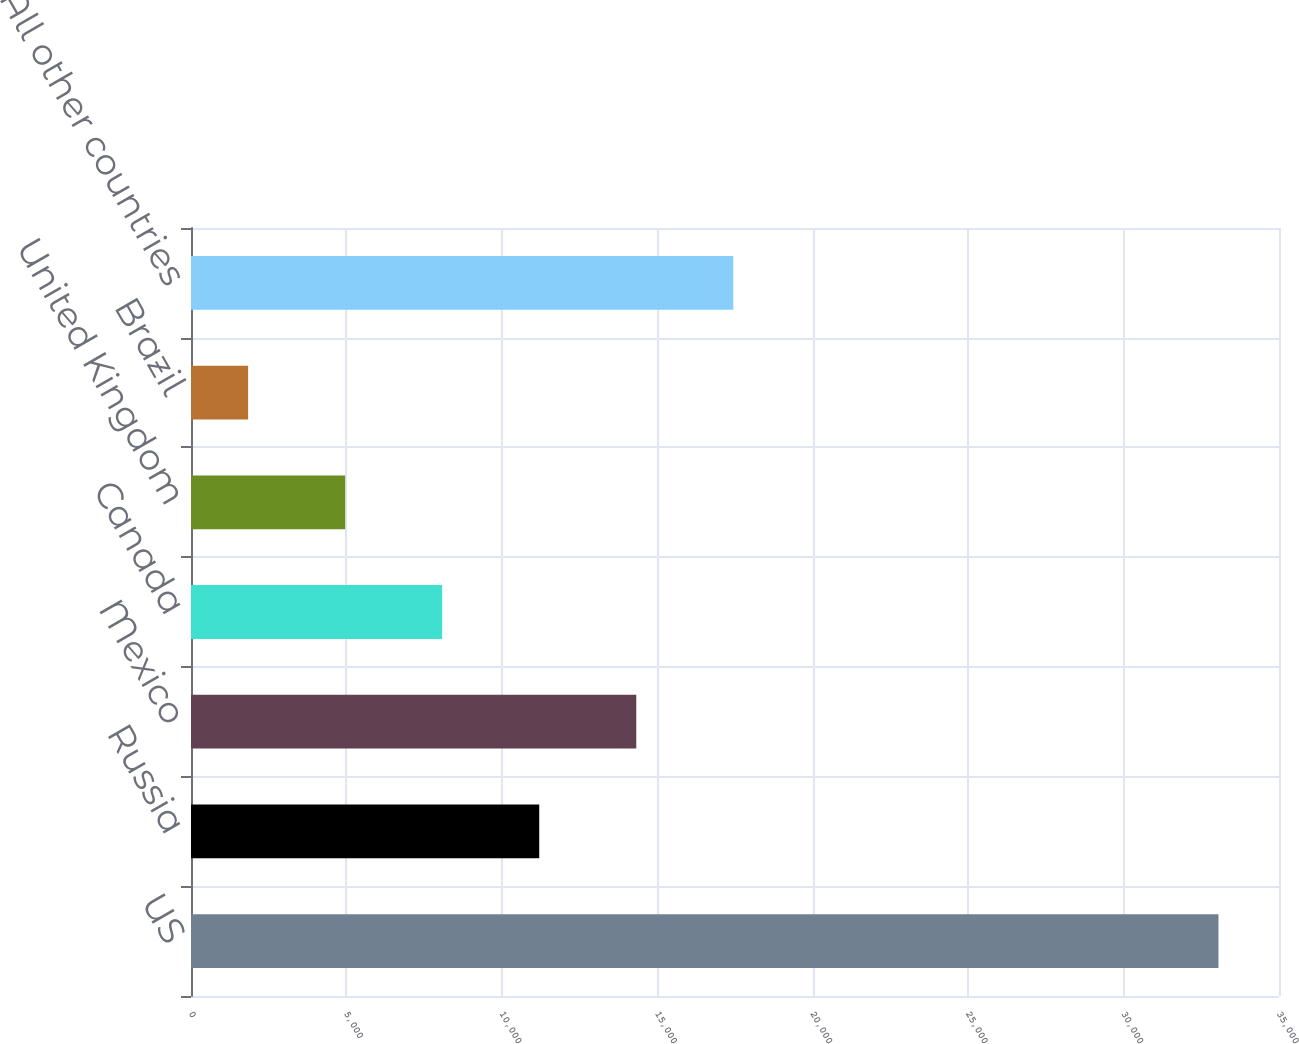Convert chart to OTSL. <chart><loc_0><loc_0><loc_500><loc_500><bar_chart><fcel>US<fcel>Russia<fcel>Mexico<fcel>Canada<fcel>United Kingdom<fcel>Brazil<fcel>All other countries<nl><fcel>33053<fcel>11202.5<fcel>14324<fcel>8081<fcel>4959.5<fcel>1838<fcel>17445.5<nl></chart> 